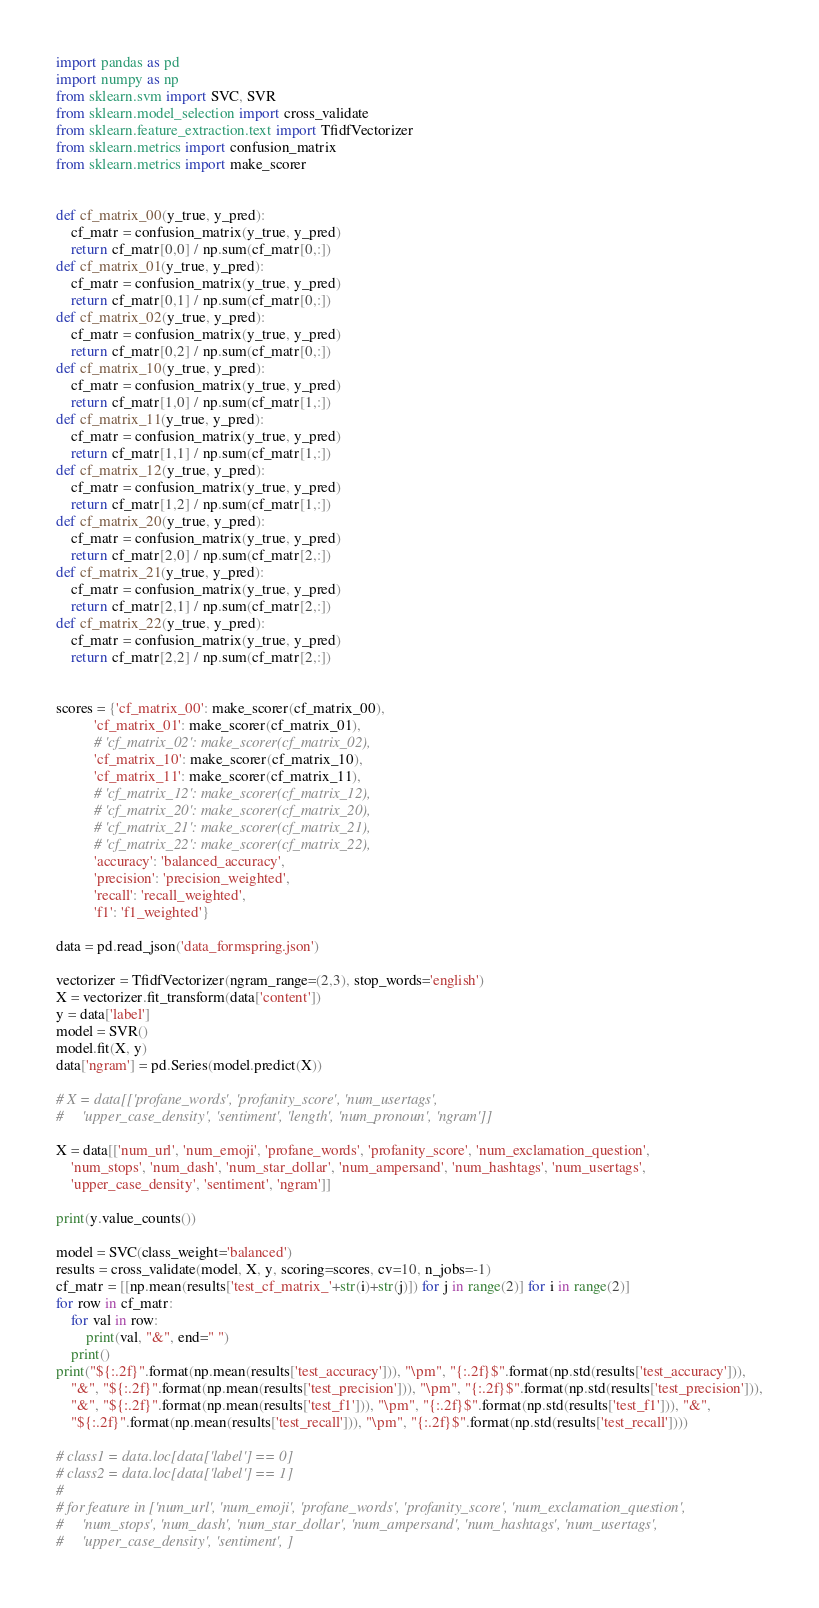<code> <loc_0><loc_0><loc_500><loc_500><_Python_>import pandas as pd
import numpy as np
from sklearn.svm import SVC, SVR
from sklearn.model_selection import cross_validate
from sklearn.feature_extraction.text import TfidfVectorizer
from sklearn.metrics import confusion_matrix
from sklearn.metrics import make_scorer


def cf_matrix_00(y_true, y_pred):
    cf_matr = confusion_matrix(y_true, y_pred)
    return cf_matr[0,0] / np.sum(cf_matr[0,:])
def cf_matrix_01(y_true, y_pred):
    cf_matr = confusion_matrix(y_true, y_pred)
    return cf_matr[0,1] / np.sum(cf_matr[0,:])
def cf_matrix_02(y_true, y_pred):
    cf_matr = confusion_matrix(y_true, y_pred)
    return cf_matr[0,2] / np.sum(cf_matr[0,:])
def cf_matrix_10(y_true, y_pred):
    cf_matr = confusion_matrix(y_true, y_pred)
    return cf_matr[1,0] / np.sum(cf_matr[1,:])
def cf_matrix_11(y_true, y_pred):
    cf_matr = confusion_matrix(y_true, y_pred)
    return cf_matr[1,1] / np.sum(cf_matr[1,:])
def cf_matrix_12(y_true, y_pred):
    cf_matr = confusion_matrix(y_true, y_pred)
    return cf_matr[1,2] / np.sum(cf_matr[1,:])
def cf_matrix_20(y_true, y_pred):
    cf_matr = confusion_matrix(y_true, y_pred)
    return cf_matr[2,0] / np.sum(cf_matr[2,:])
def cf_matrix_21(y_true, y_pred):
    cf_matr = confusion_matrix(y_true, y_pred)
    return cf_matr[2,1] / np.sum(cf_matr[2,:])
def cf_matrix_22(y_true, y_pred):
    cf_matr = confusion_matrix(y_true, y_pred)
    return cf_matr[2,2] / np.sum(cf_matr[2,:])


scores = {'cf_matrix_00': make_scorer(cf_matrix_00),
          'cf_matrix_01': make_scorer(cf_matrix_01),
          # 'cf_matrix_02': make_scorer(cf_matrix_02),
          'cf_matrix_10': make_scorer(cf_matrix_10),
          'cf_matrix_11': make_scorer(cf_matrix_11),
          # 'cf_matrix_12': make_scorer(cf_matrix_12),
          # 'cf_matrix_20': make_scorer(cf_matrix_20),
          # 'cf_matrix_21': make_scorer(cf_matrix_21),
          # 'cf_matrix_22': make_scorer(cf_matrix_22),
          'accuracy': 'balanced_accuracy',
          'precision': 'precision_weighted',
          'recall': 'recall_weighted',
          'f1': 'f1_weighted'}

data = pd.read_json('data_formspring.json')

vectorizer = TfidfVectorizer(ngram_range=(2,3), stop_words='english')
X = vectorizer.fit_transform(data['content'])
y = data['label']
model = SVR()
model.fit(X, y)
data['ngram'] = pd.Series(model.predict(X))

# X = data[['profane_words', 'profanity_score', 'num_usertags',
#     'upper_case_density', 'sentiment', 'length', 'num_pronoun', 'ngram']]

X = data[['num_url', 'num_emoji', 'profane_words', 'profanity_score', 'num_exclamation_question',
    'num_stops', 'num_dash', 'num_star_dollar', 'num_ampersand', 'num_hashtags', 'num_usertags',
    'upper_case_density', 'sentiment', 'ngram']]

print(y.value_counts())

model = SVC(class_weight='balanced')
results = cross_validate(model, X, y, scoring=scores, cv=10, n_jobs=-1)
cf_matr = [[np.mean(results['test_cf_matrix_'+str(i)+str(j)]) for j in range(2)] for i in range(2)]
for row in cf_matr:
    for val in row:
        print(val, "&", end=" ")
    print()
print("${:.2f}".format(np.mean(results['test_accuracy'])), "\pm", "{:.2f}$".format(np.std(results['test_accuracy'])),
    "&", "${:.2f}".format(np.mean(results['test_precision'])), "\pm", "{:.2f}$".format(np.std(results['test_precision'])),
    "&", "${:.2f}".format(np.mean(results['test_f1'])), "\pm", "{:.2f}$".format(np.std(results['test_f1'])), "&",
    "${:.2f}".format(np.mean(results['test_recall'])), "\pm", "{:.2f}$".format(np.std(results['test_recall'])))

# class1 = data.loc[data['label'] == 0]
# class2 = data.loc[data['label'] == 1]
#
# for feature in ['num_url', 'num_emoji', 'profane_words', 'profanity_score', 'num_exclamation_question',
#     'num_stops', 'num_dash', 'num_star_dollar', 'num_ampersand', 'num_hashtags', 'num_usertags',
#     'upper_case_density', 'sentiment', ]
</code> 